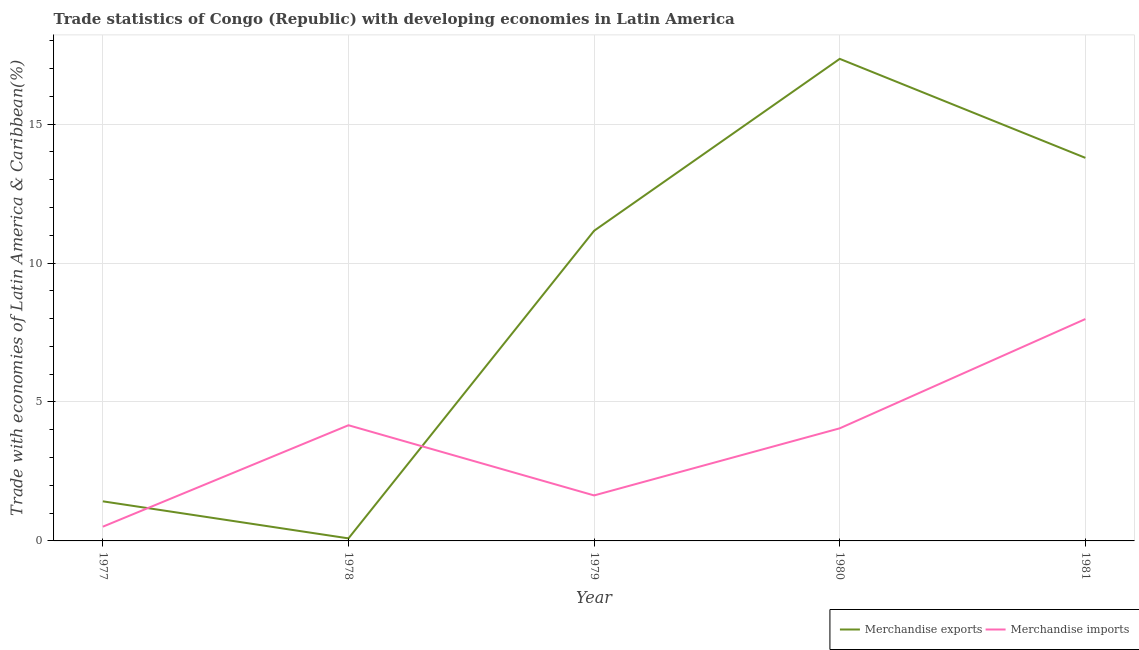How many different coloured lines are there?
Provide a short and direct response. 2. Is the number of lines equal to the number of legend labels?
Your answer should be compact. Yes. What is the merchandise imports in 1977?
Provide a short and direct response. 0.51. Across all years, what is the maximum merchandise imports?
Keep it short and to the point. 7.98. Across all years, what is the minimum merchandise imports?
Make the answer very short. 0.51. In which year was the merchandise exports maximum?
Keep it short and to the point. 1980. In which year was the merchandise imports minimum?
Your response must be concise. 1977. What is the total merchandise imports in the graph?
Provide a short and direct response. 18.35. What is the difference between the merchandise exports in 1978 and that in 1980?
Ensure brevity in your answer.  -17.26. What is the difference between the merchandise imports in 1979 and the merchandise exports in 1980?
Offer a terse response. -15.71. What is the average merchandise imports per year?
Your answer should be very brief. 3.67. In the year 1978, what is the difference between the merchandise imports and merchandise exports?
Provide a short and direct response. 4.07. What is the ratio of the merchandise exports in 1978 to that in 1981?
Offer a very short reply. 0.01. What is the difference between the highest and the second highest merchandise imports?
Offer a terse response. 3.82. What is the difference between the highest and the lowest merchandise imports?
Your answer should be very brief. 7.47. In how many years, is the merchandise exports greater than the average merchandise exports taken over all years?
Your answer should be very brief. 3. Does the merchandise exports monotonically increase over the years?
Provide a short and direct response. No. How many years are there in the graph?
Provide a short and direct response. 5. What is the difference between two consecutive major ticks on the Y-axis?
Provide a short and direct response. 5. Does the graph contain any zero values?
Provide a short and direct response. No. Where does the legend appear in the graph?
Ensure brevity in your answer.  Bottom right. How are the legend labels stacked?
Ensure brevity in your answer.  Horizontal. What is the title of the graph?
Make the answer very short. Trade statistics of Congo (Republic) with developing economies in Latin America. Does "Taxes on profits and capital gains" appear as one of the legend labels in the graph?
Keep it short and to the point. No. What is the label or title of the Y-axis?
Ensure brevity in your answer.  Trade with economies of Latin America & Caribbean(%). What is the Trade with economies of Latin America & Caribbean(%) in Merchandise exports in 1977?
Your response must be concise. 1.42. What is the Trade with economies of Latin America & Caribbean(%) of Merchandise imports in 1977?
Ensure brevity in your answer.  0.51. What is the Trade with economies of Latin America & Caribbean(%) in Merchandise exports in 1978?
Your answer should be compact. 0.09. What is the Trade with economies of Latin America & Caribbean(%) of Merchandise imports in 1978?
Offer a terse response. 4.16. What is the Trade with economies of Latin America & Caribbean(%) in Merchandise exports in 1979?
Your answer should be very brief. 11.16. What is the Trade with economies of Latin America & Caribbean(%) in Merchandise imports in 1979?
Offer a terse response. 1.64. What is the Trade with economies of Latin America & Caribbean(%) of Merchandise exports in 1980?
Keep it short and to the point. 17.35. What is the Trade with economies of Latin America & Caribbean(%) of Merchandise imports in 1980?
Ensure brevity in your answer.  4.05. What is the Trade with economies of Latin America & Caribbean(%) of Merchandise exports in 1981?
Make the answer very short. 13.78. What is the Trade with economies of Latin America & Caribbean(%) of Merchandise imports in 1981?
Ensure brevity in your answer.  7.98. Across all years, what is the maximum Trade with economies of Latin America & Caribbean(%) of Merchandise exports?
Ensure brevity in your answer.  17.35. Across all years, what is the maximum Trade with economies of Latin America & Caribbean(%) of Merchandise imports?
Your answer should be compact. 7.98. Across all years, what is the minimum Trade with economies of Latin America & Caribbean(%) of Merchandise exports?
Your response must be concise. 0.09. Across all years, what is the minimum Trade with economies of Latin America & Caribbean(%) in Merchandise imports?
Provide a succinct answer. 0.51. What is the total Trade with economies of Latin America & Caribbean(%) of Merchandise exports in the graph?
Provide a short and direct response. 43.81. What is the total Trade with economies of Latin America & Caribbean(%) in Merchandise imports in the graph?
Offer a terse response. 18.35. What is the difference between the Trade with economies of Latin America & Caribbean(%) in Merchandise imports in 1977 and that in 1978?
Provide a short and direct response. -3.65. What is the difference between the Trade with economies of Latin America & Caribbean(%) of Merchandise exports in 1977 and that in 1979?
Your response must be concise. -9.74. What is the difference between the Trade with economies of Latin America & Caribbean(%) in Merchandise imports in 1977 and that in 1979?
Offer a terse response. -1.12. What is the difference between the Trade with economies of Latin America & Caribbean(%) of Merchandise exports in 1977 and that in 1980?
Make the answer very short. -15.92. What is the difference between the Trade with economies of Latin America & Caribbean(%) in Merchandise imports in 1977 and that in 1980?
Keep it short and to the point. -3.54. What is the difference between the Trade with economies of Latin America & Caribbean(%) in Merchandise exports in 1977 and that in 1981?
Ensure brevity in your answer.  -12.36. What is the difference between the Trade with economies of Latin America & Caribbean(%) of Merchandise imports in 1977 and that in 1981?
Make the answer very short. -7.47. What is the difference between the Trade with economies of Latin America & Caribbean(%) of Merchandise exports in 1978 and that in 1979?
Ensure brevity in your answer.  -11.07. What is the difference between the Trade with economies of Latin America & Caribbean(%) in Merchandise imports in 1978 and that in 1979?
Your answer should be very brief. 2.53. What is the difference between the Trade with economies of Latin America & Caribbean(%) in Merchandise exports in 1978 and that in 1980?
Offer a very short reply. -17.26. What is the difference between the Trade with economies of Latin America & Caribbean(%) in Merchandise imports in 1978 and that in 1980?
Your answer should be very brief. 0.11. What is the difference between the Trade with economies of Latin America & Caribbean(%) of Merchandise exports in 1978 and that in 1981?
Give a very brief answer. -13.69. What is the difference between the Trade with economies of Latin America & Caribbean(%) of Merchandise imports in 1978 and that in 1981?
Offer a very short reply. -3.82. What is the difference between the Trade with economies of Latin America & Caribbean(%) of Merchandise exports in 1979 and that in 1980?
Keep it short and to the point. -6.19. What is the difference between the Trade with economies of Latin America & Caribbean(%) of Merchandise imports in 1979 and that in 1980?
Offer a terse response. -2.41. What is the difference between the Trade with economies of Latin America & Caribbean(%) of Merchandise exports in 1979 and that in 1981?
Provide a short and direct response. -2.62. What is the difference between the Trade with economies of Latin America & Caribbean(%) of Merchandise imports in 1979 and that in 1981?
Keep it short and to the point. -6.35. What is the difference between the Trade with economies of Latin America & Caribbean(%) of Merchandise exports in 1980 and that in 1981?
Offer a very short reply. 3.56. What is the difference between the Trade with economies of Latin America & Caribbean(%) of Merchandise imports in 1980 and that in 1981?
Make the answer very short. -3.93. What is the difference between the Trade with economies of Latin America & Caribbean(%) in Merchandise exports in 1977 and the Trade with economies of Latin America & Caribbean(%) in Merchandise imports in 1978?
Your answer should be compact. -2.74. What is the difference between the Trade with economies of Latin America & Caribbean(%) in Merchandise exports in 1977 and the Trade with economies of Latin America & Caribbean(%) in Merchandise imports in 1979?
Provide a succinct answer. -0.21. What is the difference between the Trade with economies of Latin America & Caribbean(%) of Merchandise exports in 1977 and the Trade with economies of Latin America & Caribbean(%) of Merchandise imports in 1980?
Ensure brevity in your answer.  -2.63. What is the difference between the Trade with economies of Latin America & Caribbean(%) in Merchandise exports in 1977 and the Trade with economies of Latin America & Caribbean(%) in Merchandise imports in 1981?
Your answer should be very brief. -6.56. What is the difference between the Trade with economies of Latin America & Caribbean(%) of Merchandise exports in 1978 and the Trade with economies of Latin America & Caribbean(%) of Merchandise imports in 1979?
Give a very brief answer. -1.55. What is the difference between the Trade with economies of Latin America & Caribbean(%) in Merchandise exports in 1978 and the Trade with economies of Latin America & Caribbean(%) in Merchandise imports in 1980?
Make the answer very short. -3.96. What is the difference between the Trade with economies of Latin America & Caribbean(%) of Merchandise exports in 1978 and the Trade with economies of Latin America & Caribbean(%) of Merchandise imports in 1981?
Offer a very short reply. -7.89. What is the difference between the Trade with economies of Latin America & Caribbean(%) of Merchandise exports in 1979 and the Trade with economies of Latin America & Caribbean(%) of Merchandise imports in 1980?
Offer a terse response. 7.11. What is the difference between the Trade with economies of Latin America & Caribbean(%) in Merchandise exports in 1979 and the Trade with economies of Latin America & Caribbean(%) in Merchandise imports in 1981?
Your answer should be compact. 3.18. What is the difference between the Trade with economies of Latin America & Caribbean(%) of Merchandise exports in 1980 and the Trade with economies of Latin America & Caribbean(%) of Merchandise imports in 1981?
Your answer should be compact. 9.36. What is the average Trade with economies of Latin America & Caribbean(%) of Merchandise exports per year?
Make the answer very short. 8.76. What is the average Trade with economies of Latin America & Caribbean(%) of Merchandise imports per year?
Your answer should be very brief. 3.67. In the year 1977, what is the difference between the Trade with economies of Latin America & Caribbean(%) of Merchandise exports and Trade with economies of Latin America & Caribbean(%) of Merchandise imports?
Make the answer very short. 0.91. In the year 1978, what is the difference between the Trade with economies of Latin America & Caribbean(%) of Merchandise exports and Trade with economies of Latin America & Caribbean(%) of Merchandise imports?
Provide a short and direct response. -4.07. In the year 1979, what is the difference between the Trade with economies of Latin America & Caribbean(%) of Merchandise exports and Trade with economies of Latin America & Caribbean(%) of Merchandise imports?
Make the answer very short. 9.52. In the year 1980, what is the difference between the Trade with economies of Latin America & Caribbean(%) in Merchandise exports and Trade with economies of Latin America & Caribbean(%) in Merchandise imports?
Provide a succinct answer. 13.29. In the year 1981, what is the difference between the Trade with economies of Latin America & Caribbean(%) of Merchandise exports and Trade with economies of Latin America & Caribbean(%) of Merchandise imports?
Provide a short and direct response. 5.8. What is the ratio of the Trade with economies of Latin America & Caribbean(%) in Merchandise exports in 1977 to that in 1978?
Provide a succinct answer. 15.59. What is the ratio of the Trade with economies of Latin America & Caribbean(%) of Merchandise imports in 1977 to that in 1978?
Your answer should be very brief. 0.12. What is the ratio of the Trade with economies of Latin America & Caribbean(%) of Merchandise exports in 1977 to that in 1979?
Your response must be concise. 0.13. What is the ratio of the Trade with economies of Latin America & Caribbean(%) of Merchandise imports in 1977 to that in 1979?
Your answer should be compact. 0.31. What is the ratio of the Trade with economies of Latin America & Caribbean(%) in Merchandise exports in 1977 to that in 1980?
Keep it short and to the point. 0.08. What is the ratio of the Trade with economies of Latin America & Caribbean(%) of Merchandise imports in 1977 to that in 1980?
Make the answer very short. 0.13. What is the ratio of the Trade with economies of Latin America & Caribbean(%) in Merchandise exports in 1977 to that in 1981?
Offer a very short reply. 0.1. What is the ratio of the Trade with economies of Latin America & Caribbean(%) in Merchandise imports in 1977 to that in 1981?
Offer a very short reply. 0.06. What is the ratio of the Trade with economies of Latin America & Caribbean(%) of Merchandise exports in 1978 to that in 1979?
Your answer should be very brief. 0.01. What is the ratio of the Trade with economies of Latin America & Caribbean(%) in Merchandise imports in 1978 to that in 1979?
Provide a succinct answer. 2.54. What is the ratio of the Trade with economies of Latin America & Caribbean(%) of Merchandise exports in 1978 to that in 1980?
Give a very brief answer. 0.01. What is the ratio of the Trade with economies of Latin America & Caribbean(%) of Merchandise imports in 1978 to that in 1980?
Keep it short and to the point. 1.03. What is the ratio of the Trade with economies of Latin America & Caribbean(%) in Merchandise exports in 1978 to that in 1981?
Ensure brevity in your answer.  0.01. What is the ratio of the Trade with economies of Latin America & Caribbean(%) of Merchandise imports in 1978 to that in 1981?
Make the answer very short. 0.52. What is the ratio of the Trade with economies of Latin America & Caribbean(%) in Merchandise exports in 1979 to that in 1980?
Ensure brevity in your answer.  0.64. What is the ratio of the Trade with economies of Latin America & Caribbean(%) in Merchandise imports in 1979 to that in 1980?
Provide a short and direct response. 0.4. What is the ratio of the Trade with economies of Latin America & Caribbean(%) of Merchandise exports in 1979 to that in 1981?
Make the answer very short. 0.81. What is the ratio of the Trade with economies of Latin America & Caribbean(%) of Merchandise imports in 1979 to that in 1981?
Your answer should be very brief. 0.2. What is the ratio of the Trade with economies of Latin America & Caribbean(%) of Merchandise exports in 1980 to that in 1981?
Give a very brief answer. 1.26. What is the ratio of the Trade with economies of Latin America & Caribbean(%) of Merchandise imports in 1980 to that in 1981?
Keep it short and to the point. 0.51. What is the difference between the highest and the second highest Trade with economies of Latin America & Caribbean(%) of Merchandise exports?
Your answer should be very brief. 3.56. What is the difference between the highest and the second highest Trade with economies of Latin America & Caribbean(%) in Merchandise imports?
Provide a succinct answer. 3.82. What is the difference between the highest and the lowest Trade with economies of Latin America & Caribbean(%) in Merchandise exports?
Your answer should be compact. 17.26. What is the difference between the highest and the lowest Trade with economies of Latin America & Caribbean(%) of Merchandise imports?
Provide a succinct answer. 7.47. 